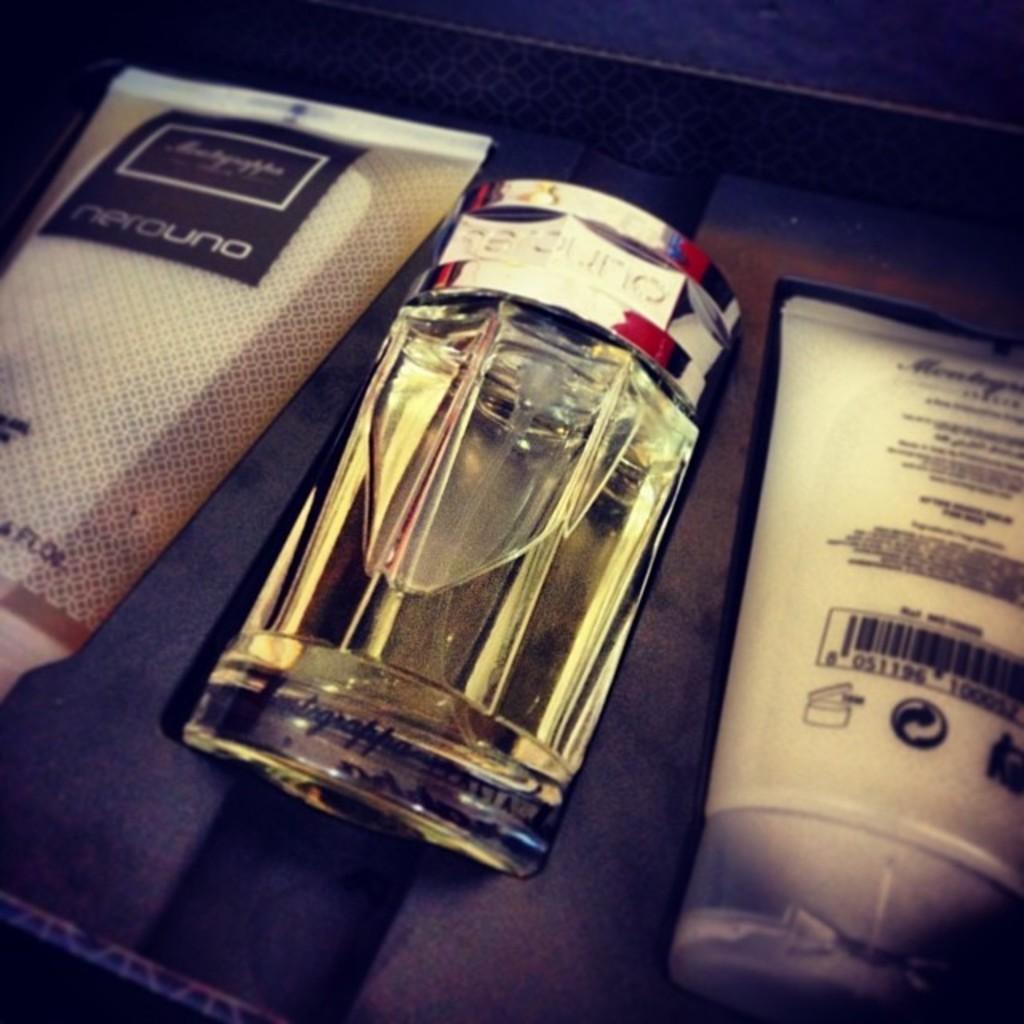What is the brand of the liquid on the left?
Offer a terse response. Nerouno. 